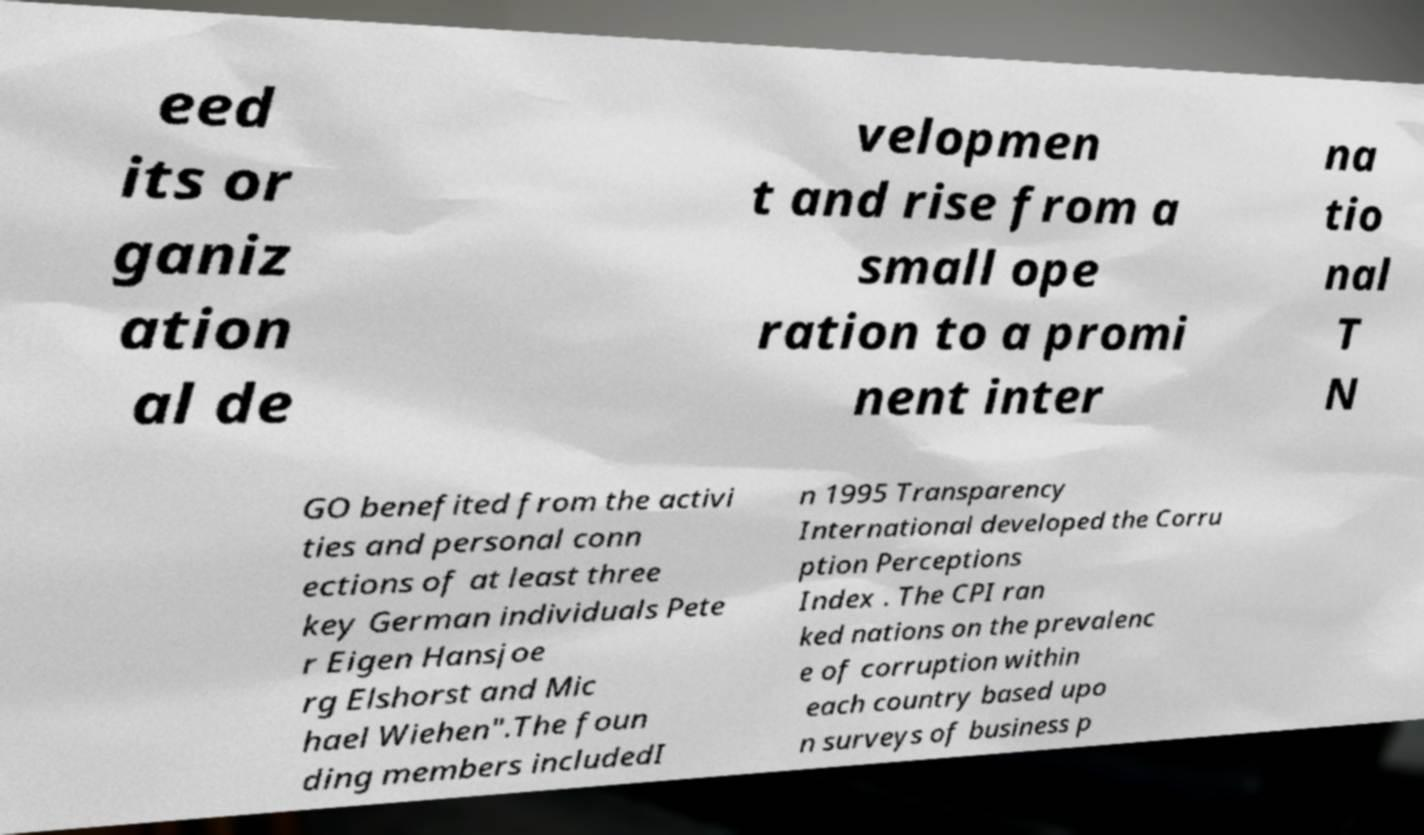There's text embedded in this image that I need extracted. Can you transcribe it verbatim? eed its or ganiz ation al de velopmen t and rise from a small ope ration to a promi nent inter na tio nal T N GO benefited from the activi ties and personal conn ections of at least three key German individuals Pete r Eigen Hansjoe rg Elshorst and Mic hael Wiehen".The foun ding members includedI n 1995 Transparency International developed the Corru ption Perceptions Index . The CPI ran ked nations on the prevalenc e of corruption within each country based upo n surveys of business p 